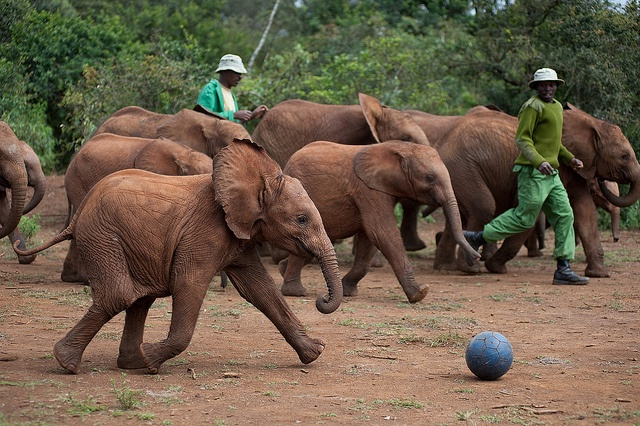Describe the objects in this image and their specific colors. I can see elephant in darkgreen, maroon, black, and brown tones, elephant in darkgreen, maroon, black, brown, and gray tones, elephant in darkgreen, black, maroon, brown, and gray tones, people in darkgreen and black tones, and elephant in darkgreen, gray, brown, and maroon tones in this image. 